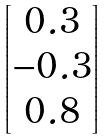<formula> <loc_0><loc_0><loc_500><loc_500>\begin{bmatrix} 0 . 3 \\ - 0 . 3 \\ 0 . 8 \end{bmatrix}</formula> 